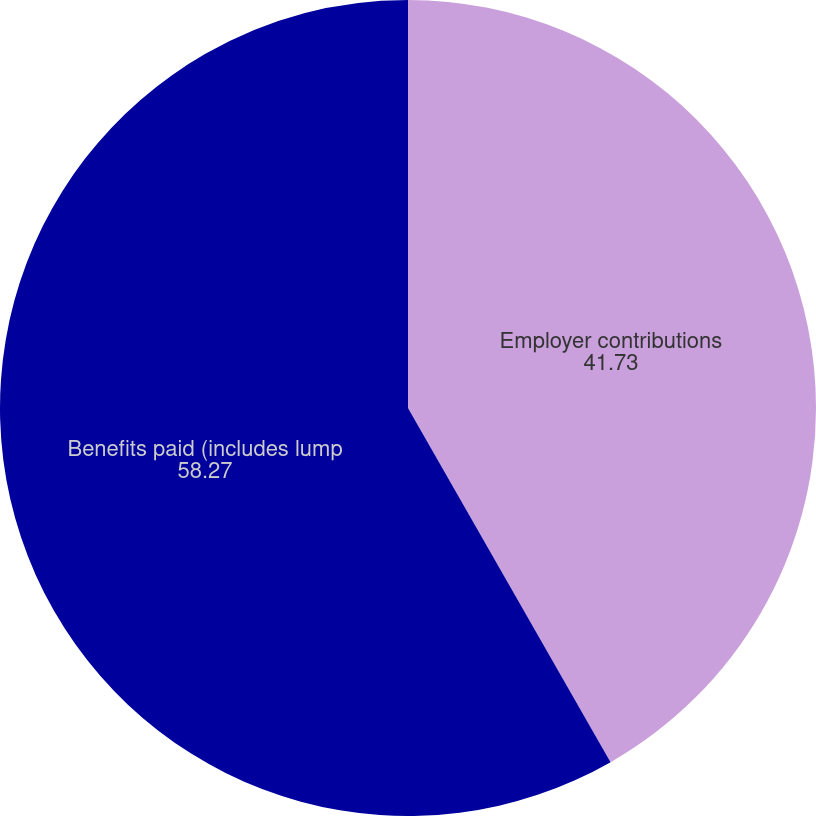Convert chart. <chart><loc_0><loc_0><loc_500><loc_500><pie_chart><fcel>Employer contributions<fcel>Benefits paid (includes lump<nl><fcel>41.73%<fcel>58.27%<nl></chart> 